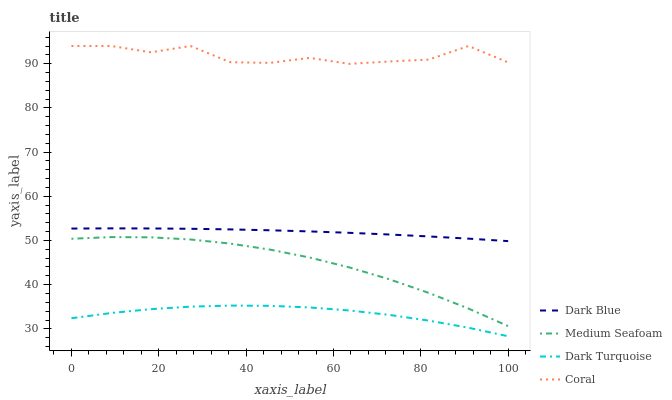Does Dark Turquoise have the minimum area under the curve?
Answer yes or no. Yes. Does Coral have the maximum area under the curve?
Answer yes or no. Yes. Does Medium Seafoam have the minimum area under the curve?
Answer yes or no. No. Does Medium Seafoam have the maximum area under the curve?
Answer yes or no. No. Is Dark Blue the smoothest?
Answer yes or no. Yes. Is Coral the roughest?
Answer yes or no. Yes. Is Medium Seafoam the smoothest?
Answer yes or no. No. Is Medium Seafoam the roughest?
Answer yes or no. No. Does Dark Turquoise have the lowest value?
Answer yes or no. Yes. Does Medium Seafoam have the lowest value?
Answer yes or no. No. Does Coral have the highest value?
Answer yes or no. Yes. Does Medium Seafoam have the highest value?
Answer yes or no. No. Is Dark Turquoise less than Dark Blue?
Answer yes or no. Yes. Is Dark Blue greater than Dark Turquoise?
Answer yes or no. Yes. Does Dark Turquoise intersect Dark Blue?
Answer yes or no. No. 